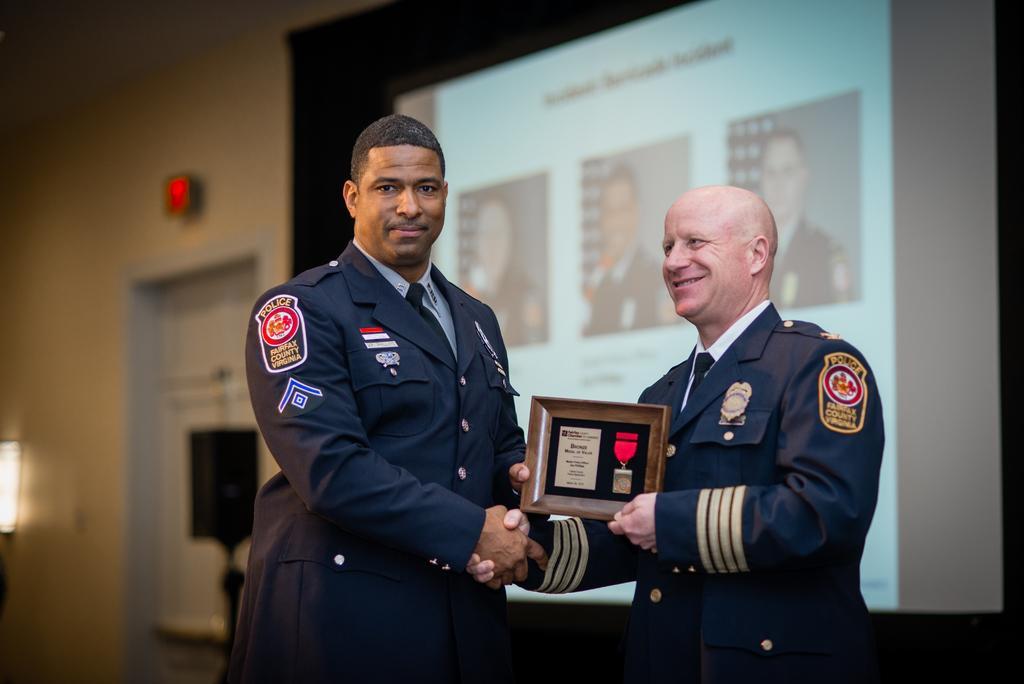Describe this image in one or two sentences. In the center of the image we can see persons standing and holding a frame. In the background we can see door and wall. 